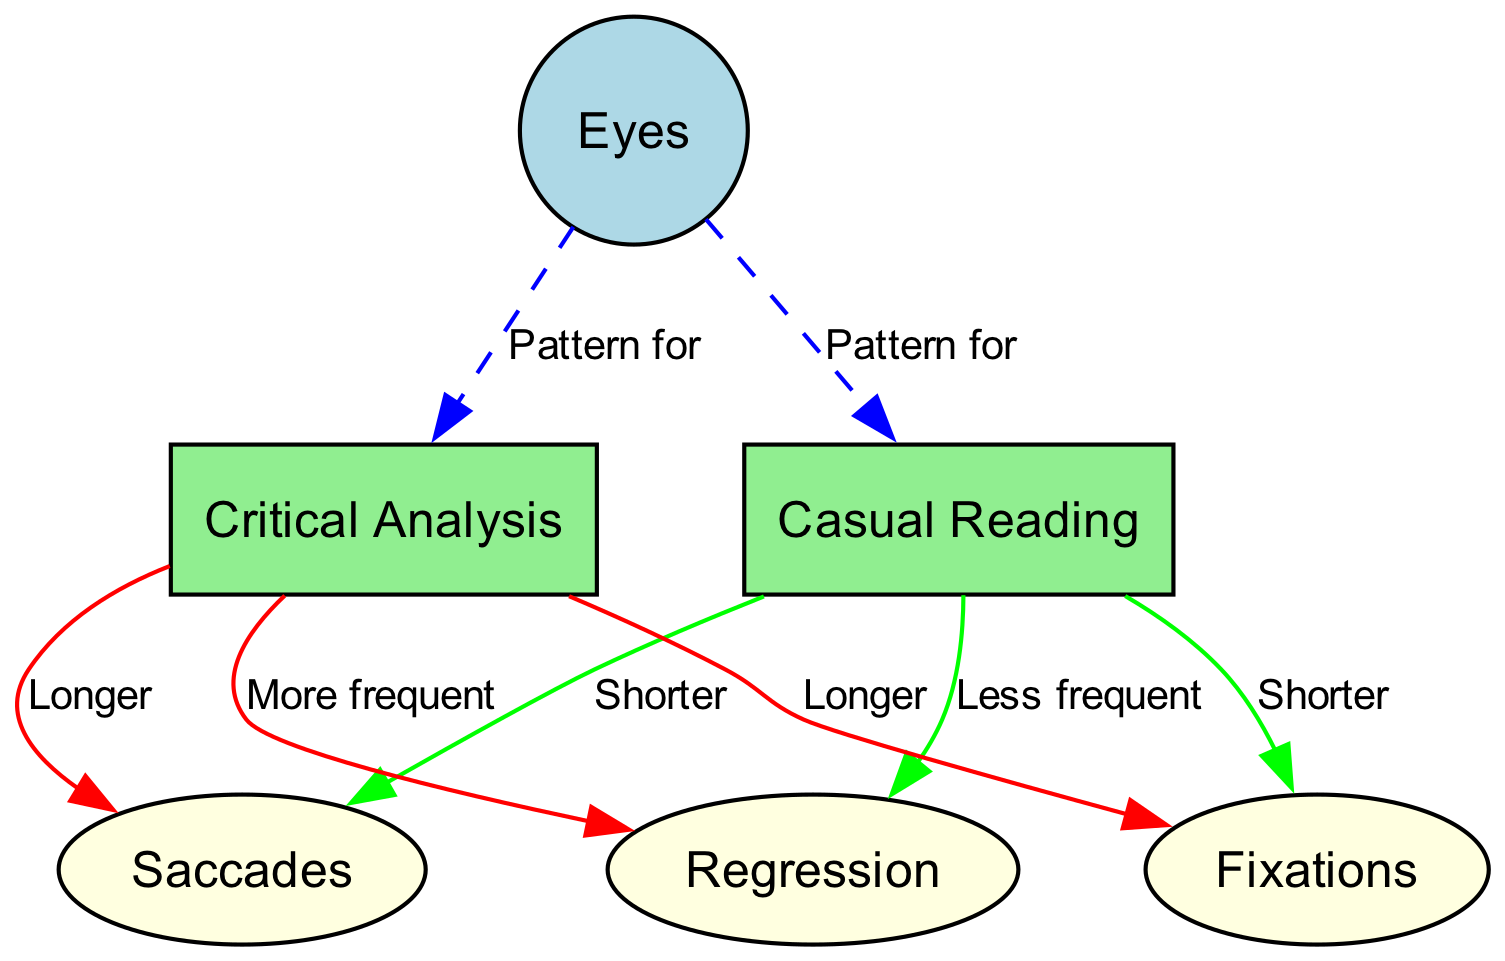What is the total number of nodes in the diagram? The diagram contains six nodes: Eyes, Casual Reading, Critical Analysis, Saccades, Fixations, and Regression.
Answer: 6 Which node represents the pattern for Casual Reading? The edge labeled "Pattern for" connects the node Eyes to the node Casual Reading, indicating that the eye movement pattern associated with Casual Reading is directly represented by this connection.
Answer: Eyes How are saccades described in the context of Critical Analysis? The edge linking Critical Analysis to Saccades states "Longer," indicating that the duration of saccades during Critical Analysis is greater than during Casual Reading.
Answer: Longer What is the frequency of regression during Casual Reading? The edge from Casual Reading to Regression is labeled "Less frequent," indicating that regression happens less often in this reading style compared to Critical Analysis.
Answer: Less frequent Which reading type shows longer fixations? The edge linking Critical Analysis to Fixations states "Longer," showing that fixations are longer during Critical Analysis than during Casual Reading.
Answer: Critical Analysis How many edges are there in the diagram? There are a total of seven edges represented in the diagram, connecting the various nodes and illustrating their relationships.
Answer: 7 What does the edge from Critical Analysis to Regression indicate? The edge states "More frequent," signifying that regression occurs more frequently in the context of Critical Analysis than in Casual Reading.
Answer: More frequent What color represents the nodes related to reading types? The nodes for Casual Reading and Critical Analysis are filled with light green, distinguishing them from the other nodes in the diagram.
Answer: Light green 